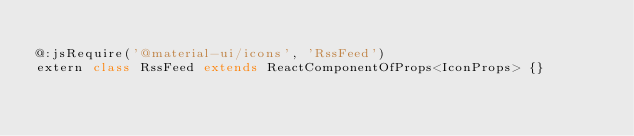<code> <loc_0><loc_0><loc_500><loc_500><_Haxe_>
@:jsRequire('@material-ui/icons', 'RssFeed')
extern class RssFeed extends ReactComponentOfProps<IconProps> {}
</code> 